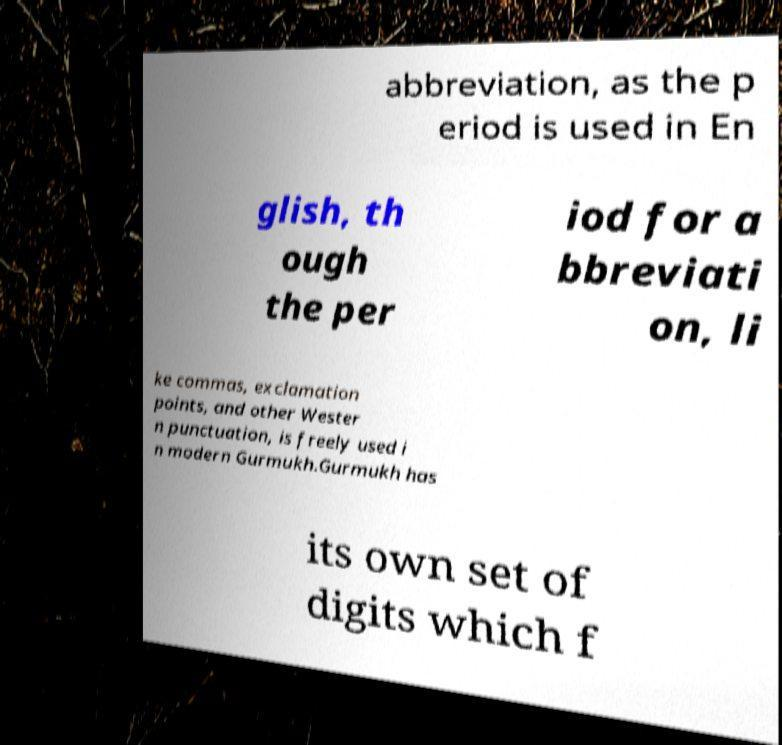Please identify and transcribe the text found in this image. abbreviation, as the p eriod is used in En glish, th ough the per iod for a bbreviati on, li ke commas, exclamation points, and other Wester n punctuation, is freely used i n modern Gurmukh.Gurmukh has its own set of digits which f 